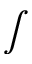<formula> <loc_0><loc_0><loc_500><loc_500>\int</formula> 